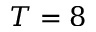Convert formula to latex. <formula><loc_0><loc_0><loc_500><loc_500>T = 8</formula> 